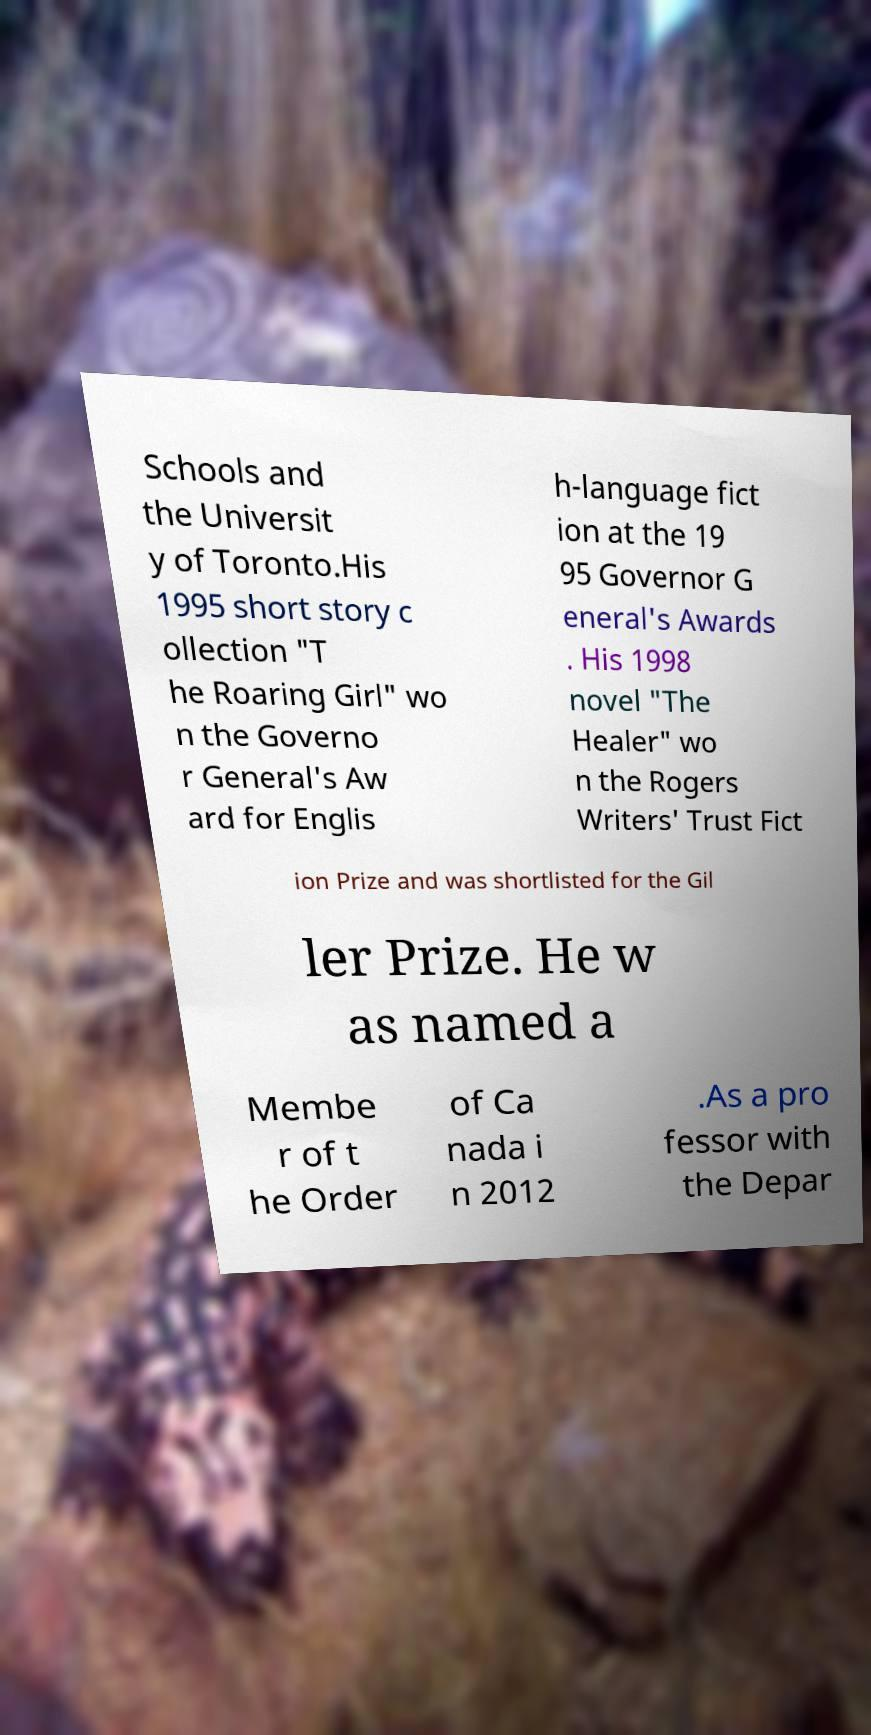Can you read and provide the text displayed in the image?This photo seems to have some interesting text. Can you extract and type it out for me? Schools and the Universit y of Toronto.His 1995 short story c ollection "T he Roaring Girl" wo n the Governo r General's Aw ard for Englis h-language fict ion at the 19 95 Governor G eneral's Awards . His 1998 novel "The Healer" wo n the Rogers Writers' Trust Fict ion Prize and was shortlisted for the Gil ler Prize. He w as named a Membe r of t he Order of Ca nada i n 2012 .As a pro fessor with the Depar 